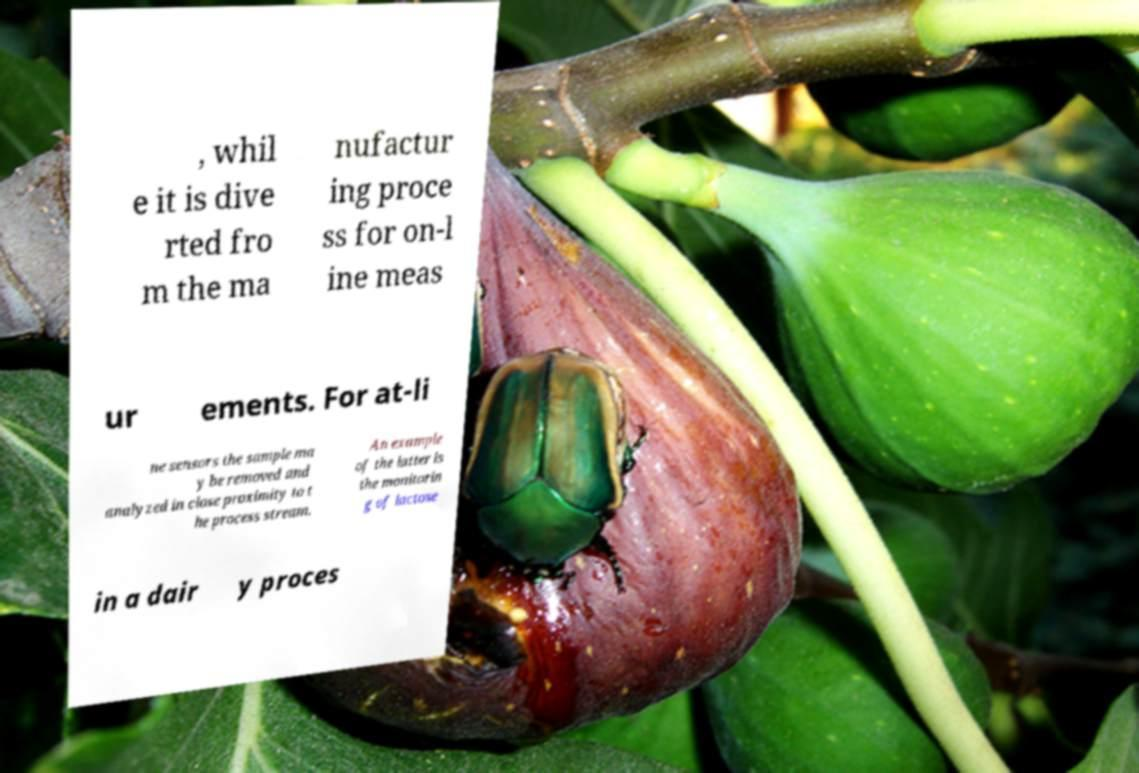Can you accurately transcribe the text from the provided image for me? , whil e it is dive rted fro m the ma nufactur ing proce ss for on-l ine meas ur ements. For at-li ne sensors the sample ma y be removed and analyzed in close proximity to t he process stream. An example of the latter is the monitorin g of lactose in a dair y proces 